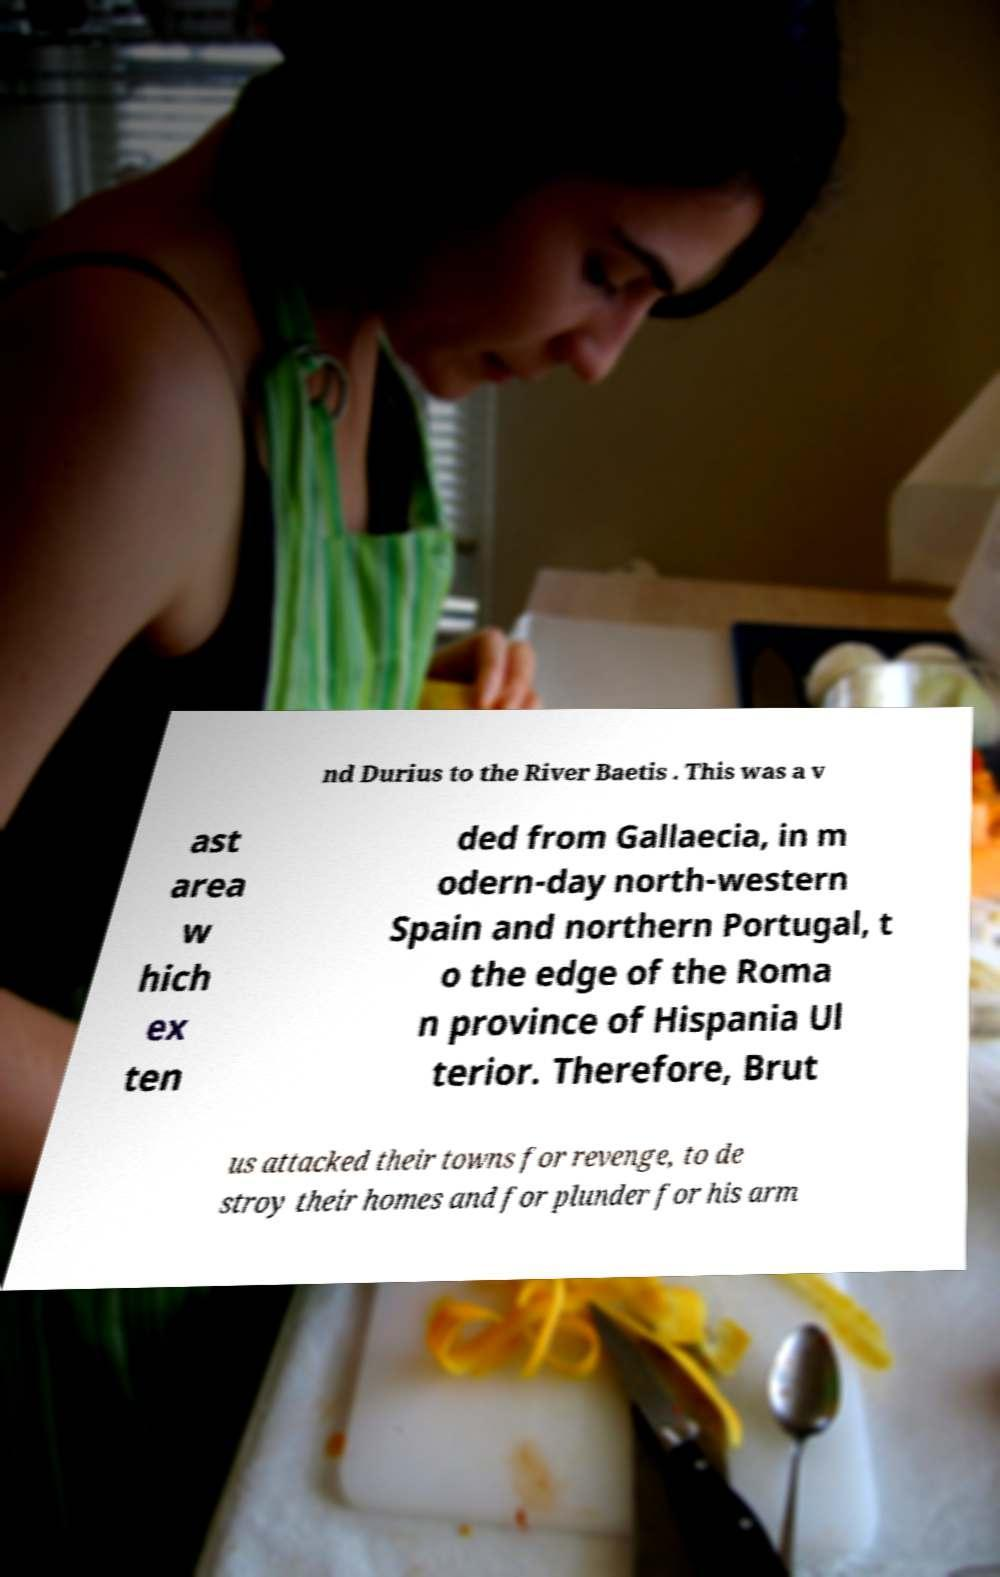What messages or text are displayed in this image? I need them in a readable, typed format. nd Durius to the River Baetis . This was a v ast area w hich ex ten ded from Gallaecia, in m odern-day north-western Spain and northern Portugal, t o the edge of the Roma n province of Hispania Ul terior. Therefore, Brut us attacked their towns for revenge, to de stroy their homes and for plunder for his arm 